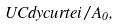<formula> <loc_0><loc_0><loc_500><loc_500>\ U C d y c u r t e i / A _ { 0 } ,</formula> 